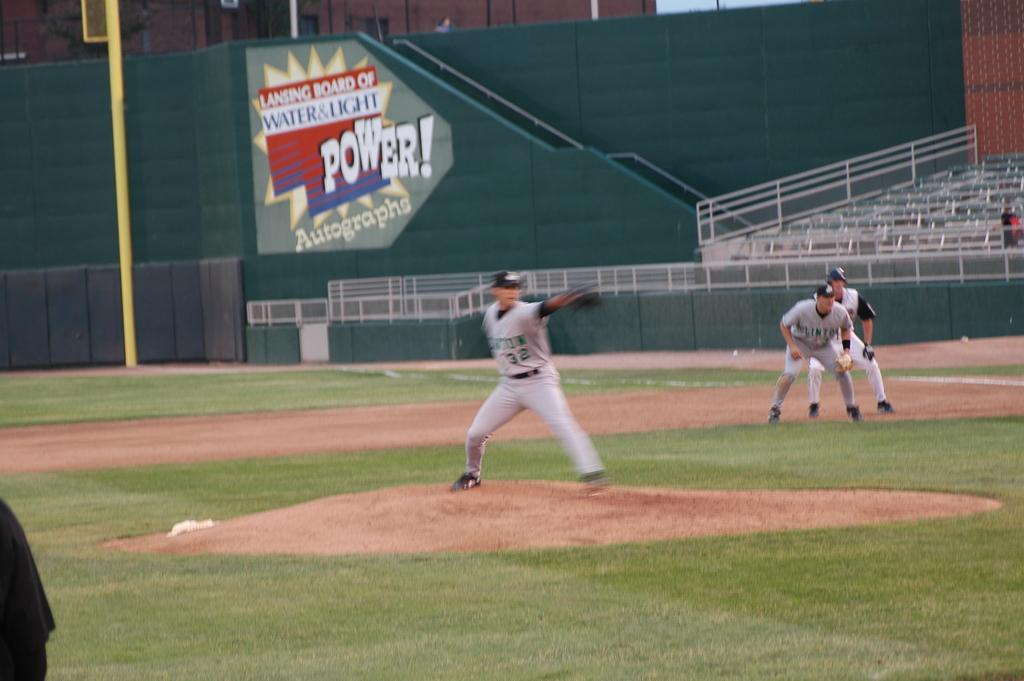<image>
Relay a brief, clear account of the picture shown. Baseball player wearing jersey number 32 is pitching the ball. 